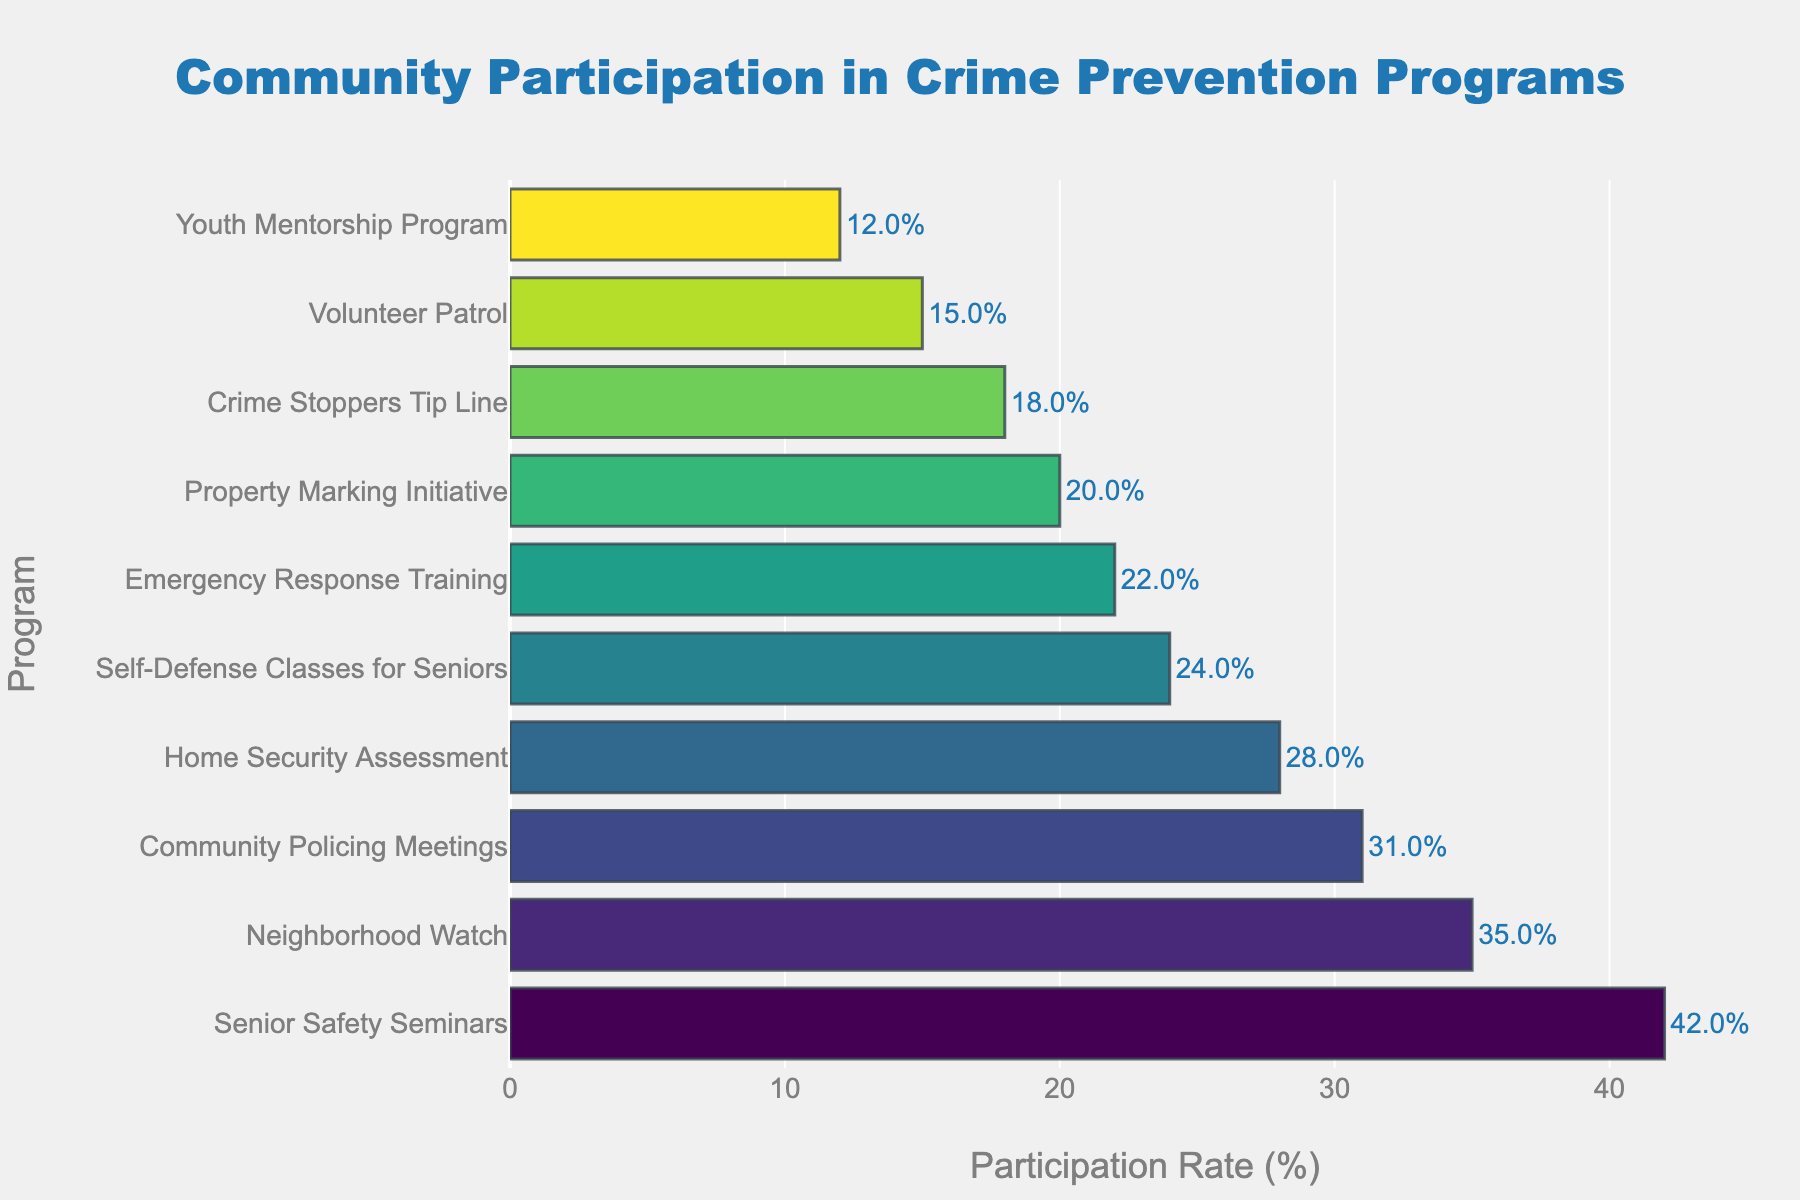What is the participation rate for the Home Security Assessment program? Locate the bar labeled "Home Security Assessment" and read the value on the x-axis where the bar ends.
Answer: 28% Which program has the highest participation rate? Find the bar that extends the furthest to the right, which represents the highest rate. The label next to this bar tells you the program name.
Answer: Senior Safety Seminars What is the difference in participation rates between the Neighborhood Watch and the Youth Mentorship Program? Identify the participation rates for both programs (35% and 12%, respectively), and subtract the smaller rate from the larger one: 35 - 12 = 23.
Answer: 23% How many programs have a participation rate higher than 30%? Count the number of bars that extend beyond the 30% mark on the x-axis.
Answer: 3 What is the average participation rate of the Volunteer Patrol and Emergency Response Training programs? Locate and sum the participation rates for both programs (15% and 22%), then divide by the number of programs: (15 + 22) / 2 = 18.5.
Answer: 18.5% Is the participation rate of the Community Policing Meetings program greater than that of the Property Marking Initiative? Compare the lengths of the bars labeled "Community Policing Meetings" (31%) and "Property Marking Initiative" (20%). Identify which bar extends further to the right.
Answer: Yes Which program has the lowest participation rate? Find the bar that extends the least to the right, which represents the lowest rate. The label next to this bar tells you the program name.
Answer: Youth Mentorship Program What is the total participation rate for the Neighborhood Watch, Home Security Assessment, and Self-Defense Classes for Seniors combined? Identify the participation rates for the three programs (35%, 28%, and 24%), then sum them up: 35 + 28 + 24 = 87.
Answer: 87% Are there more programs with a participation rate above 20% or below 20%? Count the number of programs with participation rates higher than 20% and those with rates lower than 20% and compare these counts. Above 20%: 7 programs. Below 20%: 3 programs.
Answer: Above 20% Which program has a participation rate closest to 25%? Find the program whose bar's end is nearest to the 25% mark on the x-axis. The "Self-Defense Classes for Seniors" program has a rate of 24%, which is closest.
Answer: Self-Defense Classes for Seniors 